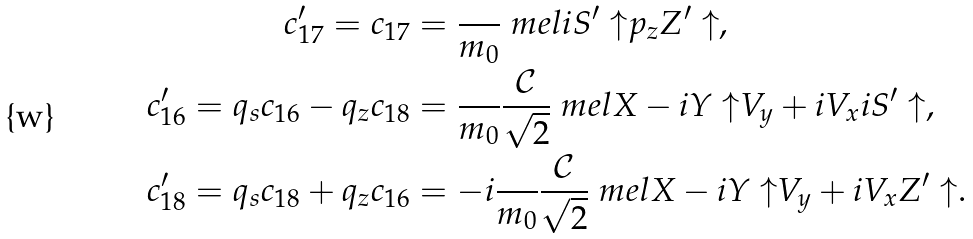<formula> <loc_0><loc_0><loc_500><loc_500>{ c ^ { \prime } _ { 1 7 } = c _ { 1 7 } } & = \frac { } { m _ { 0 } } \ m e l { i S ^ { \prime } \uparrow } { p _ { z } } { Z ^ { \prime } \uparrow } , \\ { c ^ { \prime } _ { 1 6 } } = q _ { s } { c _ { 1 6 } } - q _ { z } { c _ { 1 8 } } & = \frac { } { m _ { 0 } } \frac { \mathcal { C } } { \sqrt { 2 } } \ m e l { X - i Y \uparrow } { V _ { y } + i V _ { x } } { i S ^ { \prime } \uparrow } , \\ { c ^ { \prime } _ { 1 8 } } = q _ { s } { c _ { 1 8 } } + q _ { z } { c _ { 1 6 } } & = - i \frac { } { m _ { 0 } } \frac { \mathcal { C } } { \sqrt { 2 } } \ m e l { X - i Y \uparrow } { V _ { y } + i V _ { x } } { Z ^ { \prime } \uparrow } .</formula> 